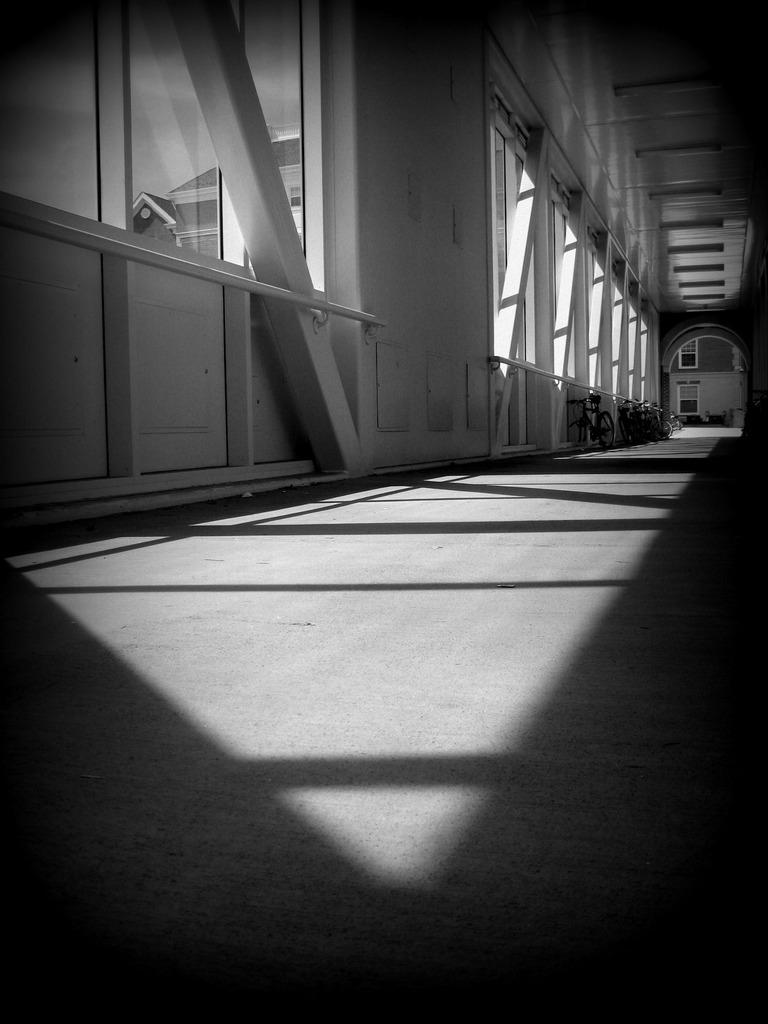What is the color scheme of the image? The image is black and white. What type of structure can be seen in the image? There is a corridor in the image. What feature is present on the sides of the corridor? There are windows on the sides of the corridor. What objects can be seen in the image? There are rods and vehicles in the image. What architectural element is visible in the background of the image? There is an arch in the background of the image. What type of store can be seen in the image? There is no store present in the image. What time of day is it in the image, based on the lighting and shadows? The image is black and white, so it is not possible to determine the time of day based on lighting and shadows. 